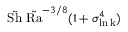<formula> <loc_0><loc_0><loc_500><loc_500>\tilde { S h } \ \tilde { R a } ^ { - 3 / 8 } ( 1 + \sigma _ { \ln k } ^ { 4 } )</formula> 